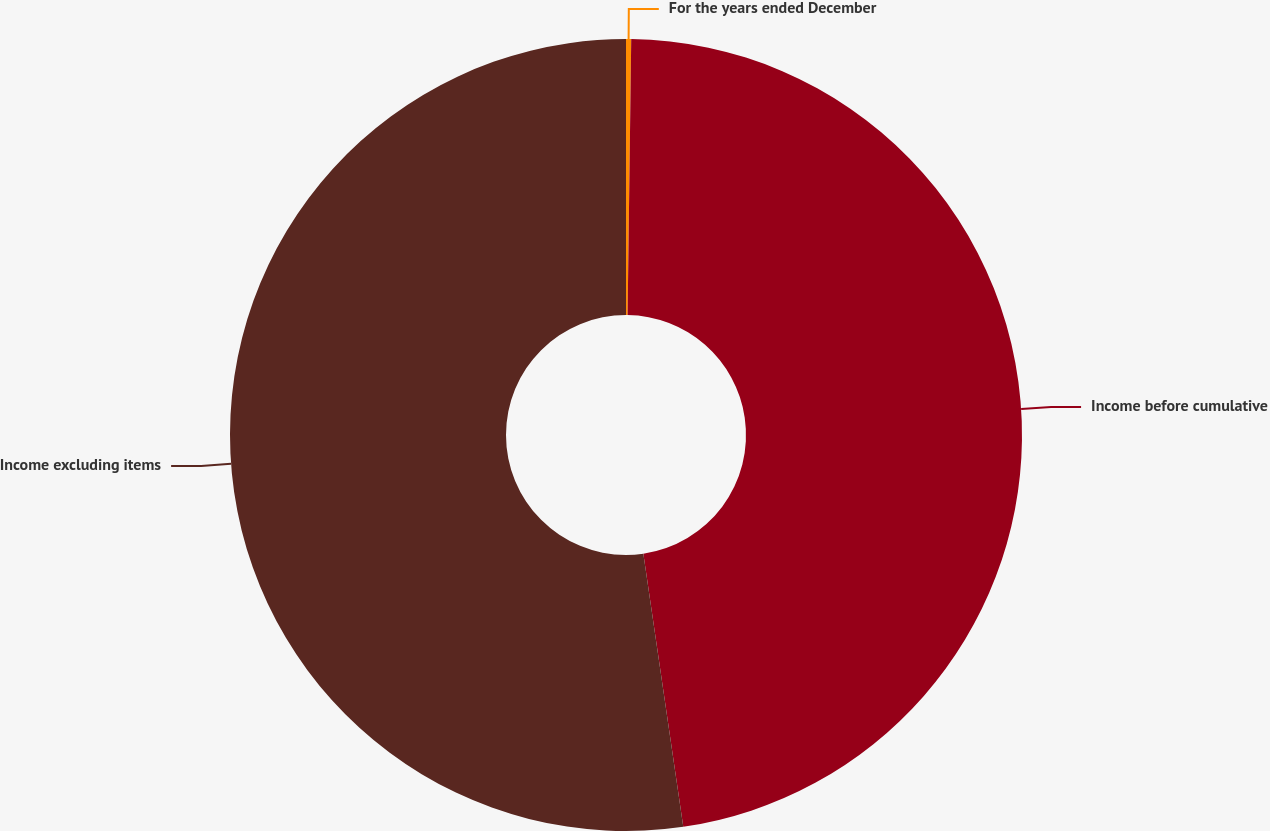<chart> <loc_0><loc_0><loc_500><loc_500><pie_chart><fcel>For the years ended December<fcel>Income before cumulative<fcel>Income excluding items<nl><fcel>0.21%<fcel>47.48%<fcel>52.31%<nl></chart> 